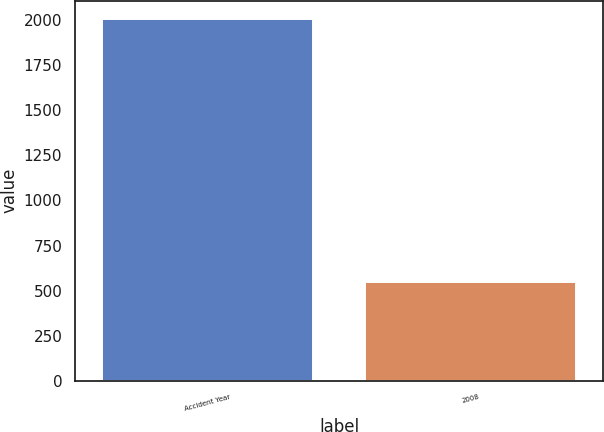<chart> <loc_0><loc_0><loc_500><loc_500><bar_chart><fcel>Accident Year<fcel>2008<nl><fcel>2008<fcel>548<nl></chart> 